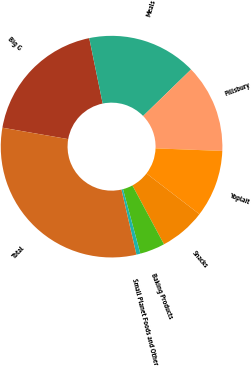<chart> <loc_0><loc_0><loc_500><loc_500><pie_chart><fcel>Big G<fcel>Meals<fcel>Pillsbury<fcel>Yoplait<fcel>Snacks<fcel>Baking Products<fcel>Small Planet Foods and Other<fcel>Total<nl><fcel>19.03%<fcel>15.96%<fcel>12.88%<fcel>9.81%<fcel>6.73%<fcel>3.66%<fcel>0.58%<fcel>31.33%<nl></chart> 